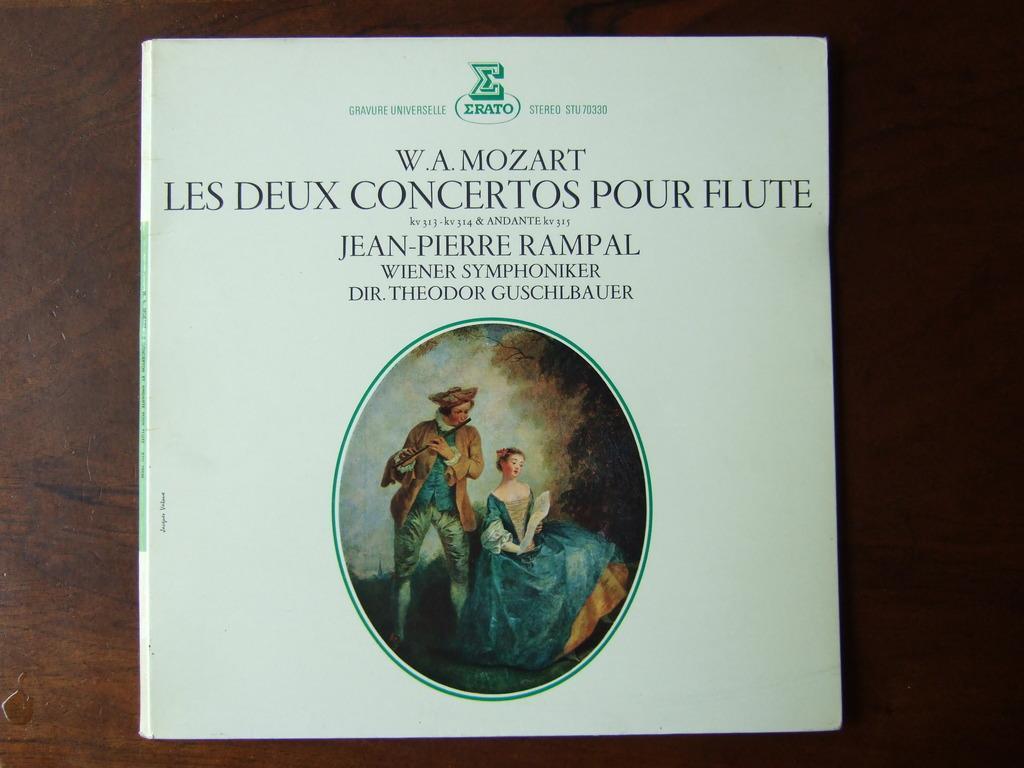How would you summarize this image in a sentence or two? In this image there is a front cover of a book, there is an image and some text on it. 